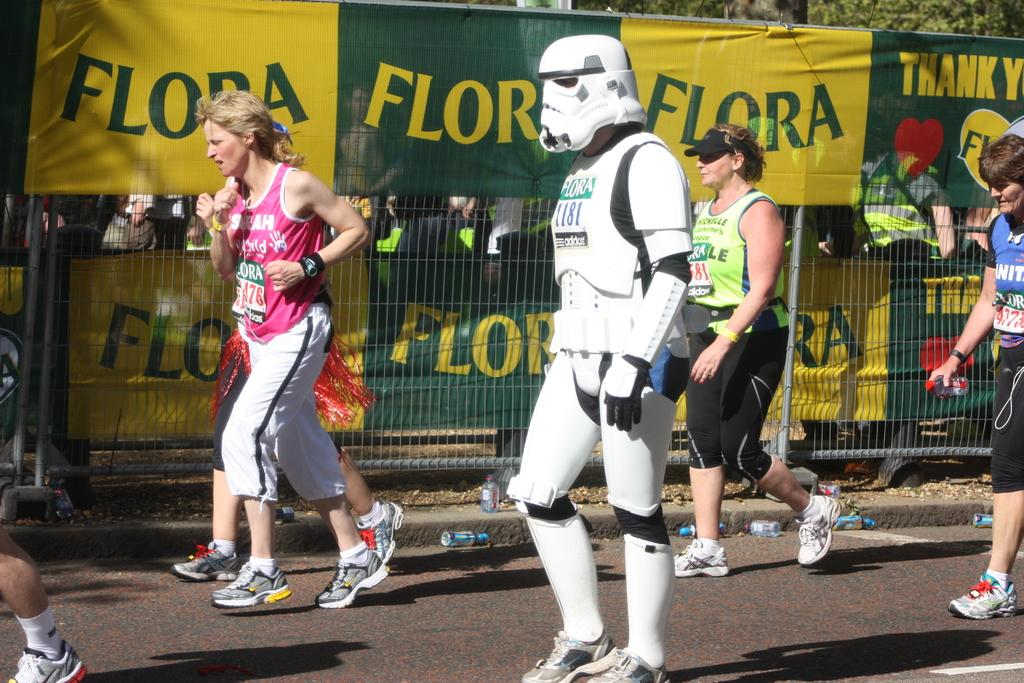<image>
Give a short and clear explanation of the subsequent image. the words Flora and Thank you that are on some signs 